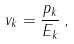<formula> <loc_0><loc_0><loc_500><loc_500>v _ { k } = \frac { p _ { k } } { E _ { k } } \, ,</formula> 